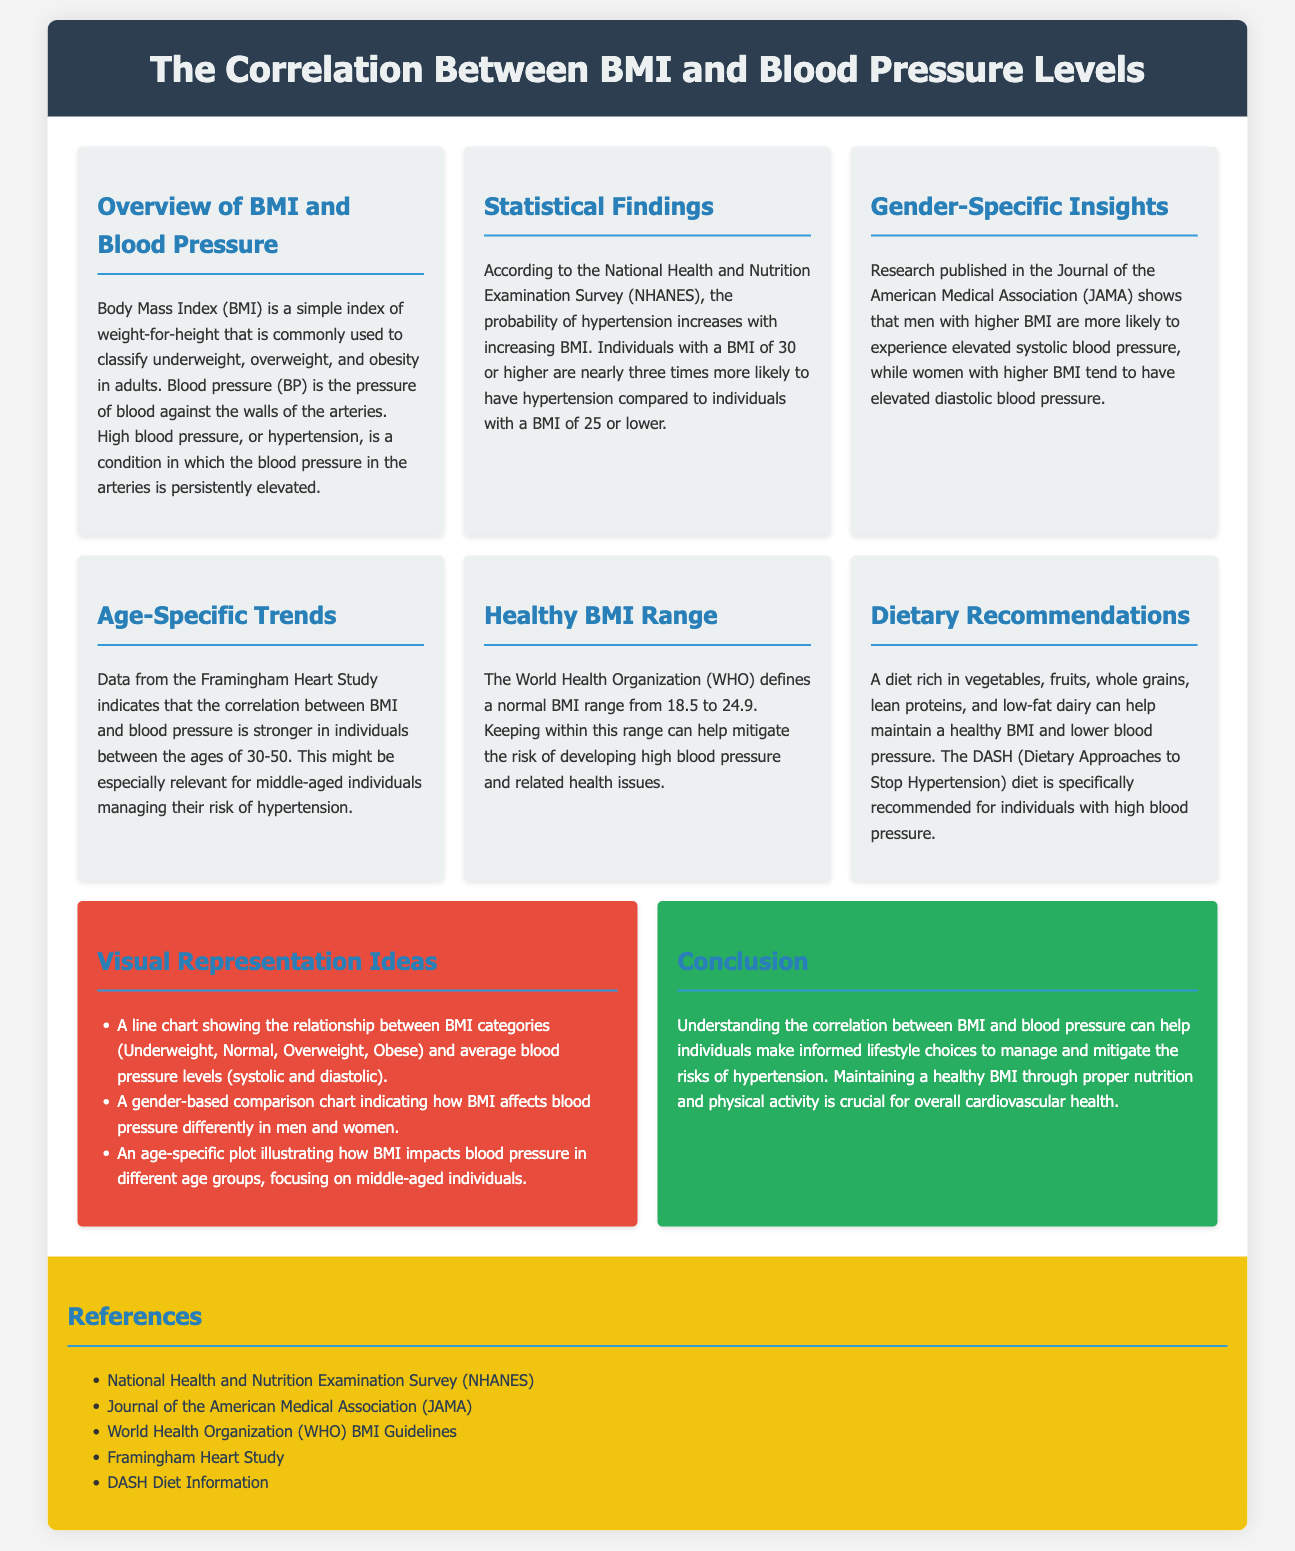What is BMI? BMI is a simple index of weight-for-height that is commonly used to classify underweight, overweight, and obesity in adults.
Answer: A simple index of weight-for-height What is the BMI threshold for higher hypertension risk? Individuals with a BMI of 30 or higher are nearly three times more likely to have hypertension compared to those with a BMI of 25 or lower.
Answer: BMI of 30 or higher Which age group shows a stronger correlation between BMI and blood pressure? The correlation between BMI and blood pressure is stronger in individuals between the ages of 30-50.
Answer: Ages 30-50 What dietary approach is recommended for individuals with high blood pressure? The DASH (Dietary Approaches to Stop Hypertension) diet is specifically recommended for individuals with high blood pressure.
Answer: DASH diet What two types of blood pressure may be affected by higher BMI in men and women? Men tend to experience elevated systolic blood pressure, while women tend to have elevated diastolic blood pressure.
Answer: Systolic and diastolic How does maintaining a healthy BMI benefit individuals? Maintaining a healthy BMI can help mitigate the risk of developing high blood pressure and related health issues.
Answer: Mitigates risk of high blood pressure 